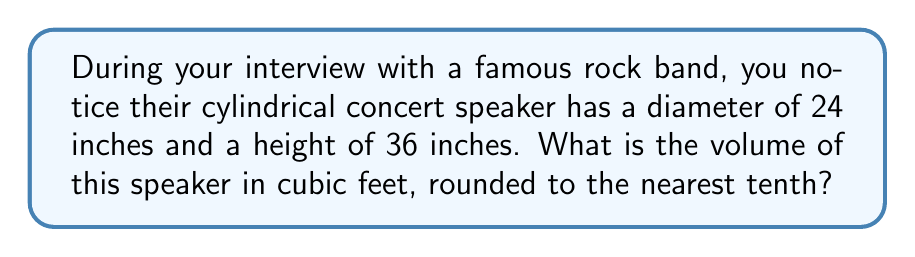What is the answer to this math problem? Let's approach this step-by-step:

1) The formula for the volume of a cylinder is:
   $$V = \pi r^2 h$$
   where $r$ is the radius and $h$ is the height.

2) We're given the diameter (24 inches) and height (36 inches). We need the radius:
   $$r = \frac{diameter}{2} = \frac{24}{2} = 12 \text{ inches}$$

3) Now we can substitute into our formula:
   $$V = \pi (12 \text{ in})^2 (36 \text{ in})$$

4) Simplify:
   $$V = \pi (144 \text{ in}^2) (36 \text{ in}) = 5184\pi \text{ in}^3$$

5) We need to convert cubic inches to cubic feet. There are 1728 cubic inches in a cubic foot:
   $$V = \frac{5184\pi}{1728} \text{ ft}^3 = 3\pi \text{ ft}^3$$

6) Calculate and round to the nearest tenth:
   $$V \approx 9.4 \text{ ft}^3$$
Answer: 9.4 ft³ 